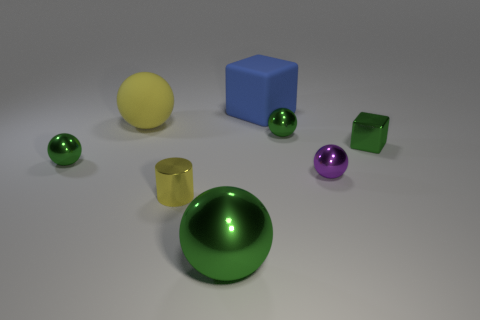Subtract all cyan cylinders. How many green balls are left? 3 Subtract all yellow spheres. How many spheres are left? 4 Subtract all yellow spheres. How many spheres are left? 4 Subtract all cyan spheres. Subtract all cyan cylinders. How many spheres are left? 5 Add 2 tiny shiny balls. How many objects exist? 10 Subtract all balls. How many objects are left? 3 Add 8 large green objects. How many large green objects are left? 9 Add 4 large blocks. How many large blocks exist? 5 Subtract 0 brown balls. How many objects are left? 8 Subtract all things. Subtract all gray rubber balls. How many objects are left? 0 